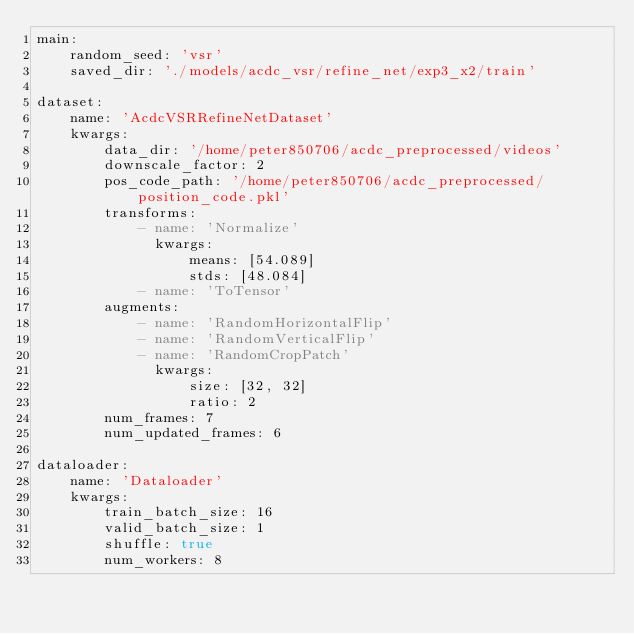<code> <loc_0><loc_0><loc_500><loc_500><_YAML_>main:
    random_seed: 'vsr'
    saved_dir: './models/acdc_vsr/refine_net/exp3_x2/train'
    
dataset:
    name: 'AcdcVSRRefineNetDataset'
    kwargs:
        data_dir: '/home/peter850706/acdc_preprocessed/videos'
        downscale_factor: 2
        pos_code_path: '/home/peter850706/acdc_preprocessed/position_code.pkl'
        transforms:
            - name: 'Normalize'
              kwargs:
                  means: [54.089]
                  stds: [48.084]
            - name: 'ToTensor'
        augments:
            - name: 'RandomHorizontalFlip'
            - name: 'RandomVerticalFlip'
            - name: 'RandomCropPatch'
              kwargs:
                  size: [32, 32]
                  ratio: 2
        num_frames: 7
        num_updated_frames: 6

dataloader:
    name: 'Dataloader'
    kwargs:
        train_batch_size: 16
        valid_batch_size: 1
        shuffle: true
        num_workers: 8
</code> 